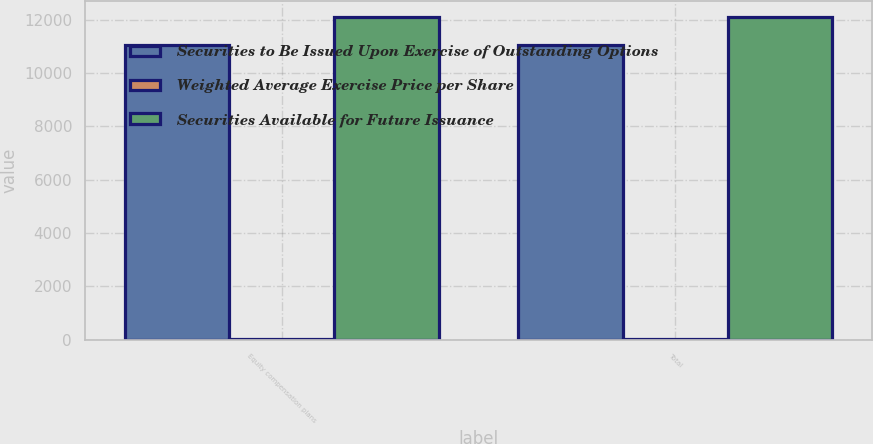Convert chart. <chart><loc_0><loc_0><loc_500><loc_500><stacked_bar_chart><ecel><fcel>Equity compensation plans<fcel>Total<nl><fcel>Securities to Be Issued Upon Exercise of Outstanding Options<fcel>11046<fcel>11046<nl><fcel>Weighted Average Exercise Price per Share<fcel>31.33<fcel>31.33<nl><fcel>Securities Available for Future Issuance<fcel>12095<fcel>12095<nl></chart> 